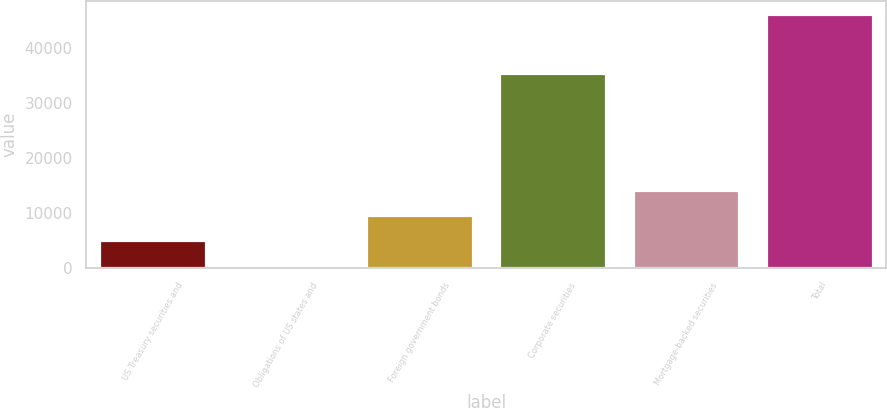Convert chart to OTSL. <chart><loc_0><loc_0><loc_500><loc_500><bar_chart><fcel>US Treasury securities and<fcel>Obligations of US states and<fcel>Foreign government bonds<fcel>Corporate securities<fcel>Mortgage-backed securities<fcel>Total<nl><fcel>5052<fcel>470<fcel>9634<fcel>35487<fcel>14216<fcel>46290<nl></chart> 